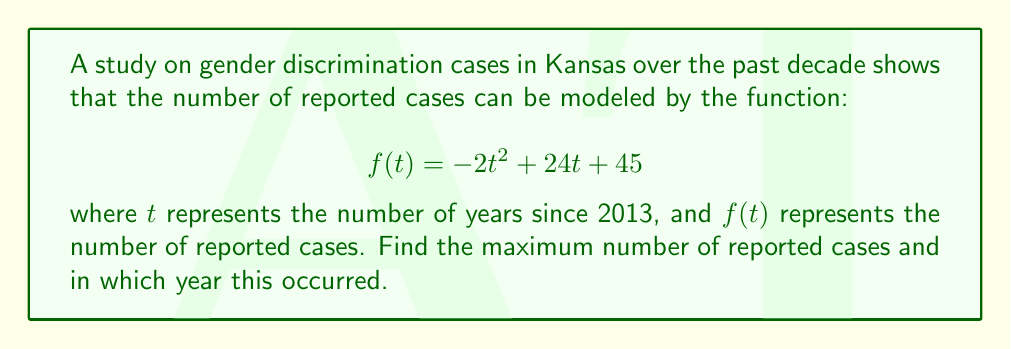Can you answer this question? To find the maximum point of this quadratic function, we need to follow these steps:

1) The general form of a quadratic function is $f(t) = at^2 + bt + c$, where $a$, $b$, and $c$ are constants and $a \neq 0$. In this case, $a = -2$, $b = 24$, and $c = 45$.

2) For a quadratic function, the t-coordinate of the vertex (which gives the maximum or minimum point) is given by the formula:

   $$t = -\frac{b}{2a}$$

3) Substituting our values:

   $$t = -\frac{24}{2(-2)} = -\frac{24}{-4} = 6$$

4) This means the maximum occurs 6 years after 2013, which is 2019.

5) To find the maximum number of cases, we substitute $t = 6$ into the original function:

   $$f(6) = -2(6)^2 + 24(6) + 45$$
   $$    = -2(36) + 144 + 45$$
   $$    = -72 + 144 + 45$$
   $$    = 117$$

Therefore, the maximum number of reported cases is 117, occurring in 2019.
Answer: The maximum number of reported gender discrimination cases in Kansas was 117, occurring in 2019. 